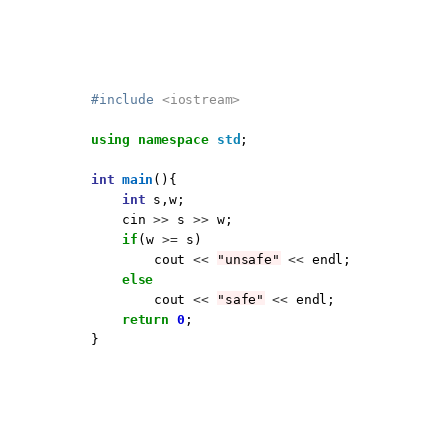<code> <loc_0><loc_0><loc_500><loc_500><_C++_>#include <iostream>

using namespace std;

int main(){
	int s,w;
	cin >> s >> w;
	if(w >= s)
		cout << "unsafe" << endl;
	else
		cout << "safe" << endl;
	return 0;
}
</code> 